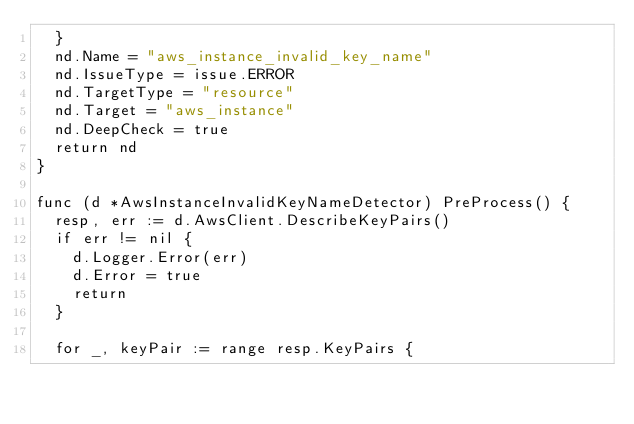<code> <loc_0><loc_0><loc_500><loc_500><_Go_>	}
	nd.Name = "aws_instance_invalid_key_name"
	nd.IssueType = issue.ERROR
	nd.TargetType = "resource"
	nd.Target = "aws_instance"
	nd.DeepCheck = true
	return nd
}

func (d *AwsInstanceInvalidKeyNameDetector) PreProcess() {
	resp, err := d.AwsClient.DescribeKeyPairs()
	if err != nil {
		d.Logger.Error(err)
		d.Error = true
		return
	}

	for _, keyPair := range resp.KeyPairs {</code> 